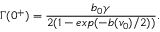<formula> <loc_0><loc_0><loc_500><loc_500>\Gamma ( 0 ^ { + } ) = \frac { b _ { 0 } \gamma } { 2 ( 1 - e x p ( - b ( v _ { 0 } ) / 2 ) ) } .</formula> 